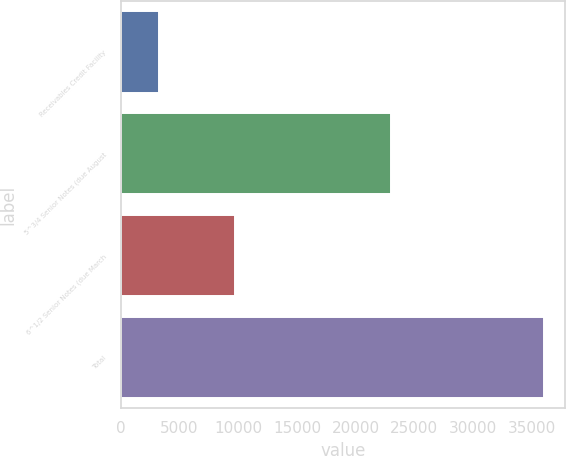<chart> <loc_0><loc_0><loc_500><loc_500><bar_chart><fcel>Receivables Credit Facility<fcel>5^3/4 Senior Notes (due August<fcel>6^1/2 Senior Notes (due March<fcel>Total<nl><fcel>3280<fcel>23000<fcel>9750<fcel>36030<nl></chart> 